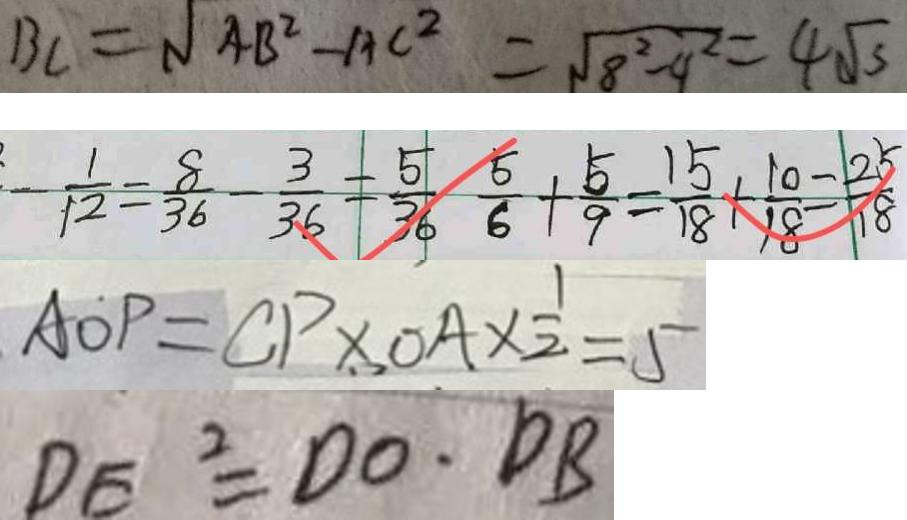<formula> <loc_0><loc_0><loc_500><loc_500>B C = \sqrt { 4 B ^ { 2 } - A C ^ { 2 } } = \sqrt { 8 ^ { 2 } - 9 ^ { 2 } } = 4 \sqrt { 3 } 
 - \frac { 1 } { 1 2 } = \frac { 8 } { 3 6 } - \frac { 3 } { 3 6 } = \frac { 5 } { 3 6 } \frac { 5 } { 6 } + \frac { 5 } { 9 } = \frac { 1 5 } { 1 8 } + \frac { 1 0 } { 1 8 } = \frac { 2 5 } { 1 8 } 
 A O P = C P \times O A \times \frac { 1 } { 2 } = 5 
 D E ^ { 2 } = D O \cdot D B</formula> 